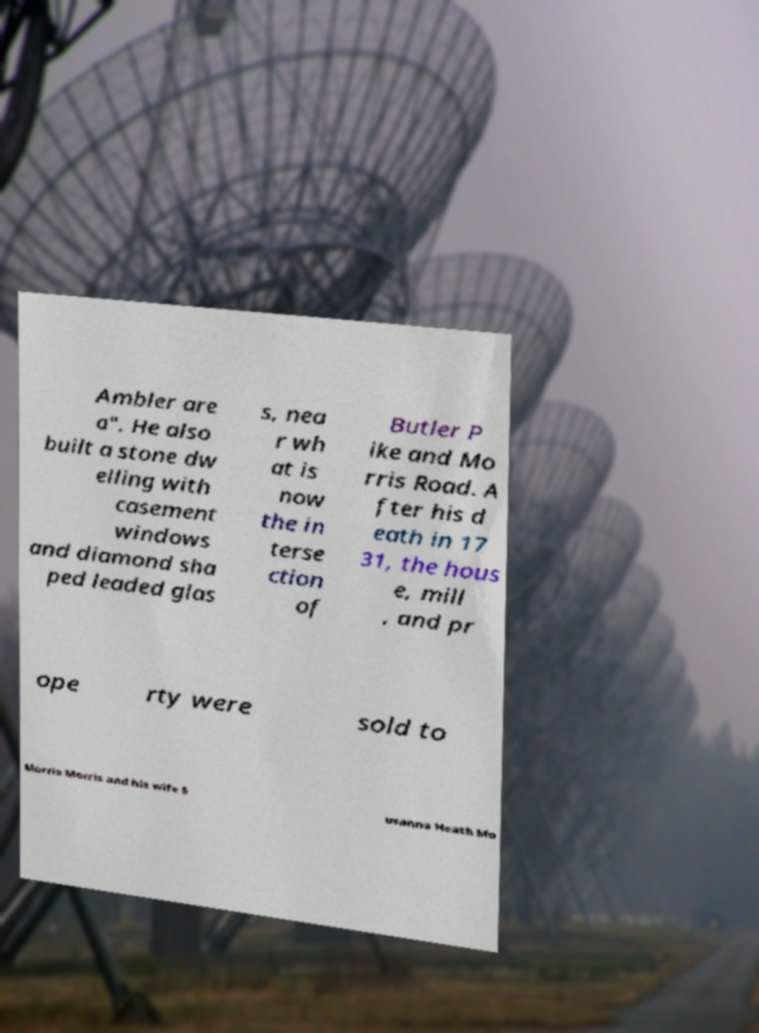Please read and relay the text visible in this image. What does it say? Ambler are a". He also built a stone dw elling with casement windows and diamond sha ped leaded glas s, nea r wh at is now the in terse ction of Butler P ike and Mo rris Road. A fter his d eath in 17 31, the hous e, mill , and pr ope rty were sold to Morris Morris and his wife S usanna Heath Mo 